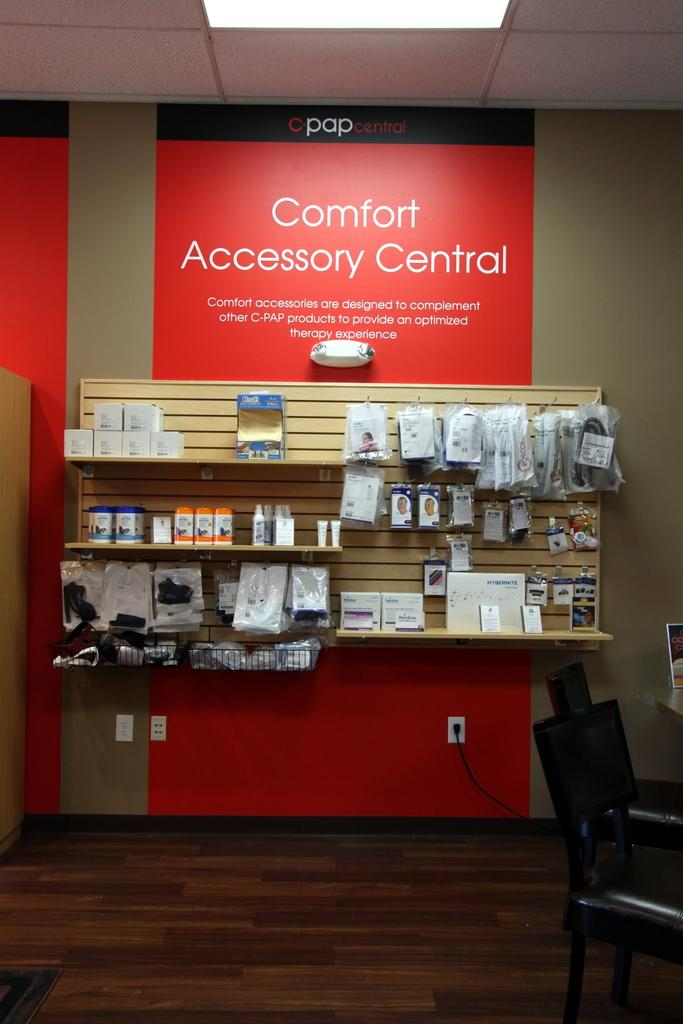<image>
Present a compact description of the photo's key features. A comfort accessory display featuring a variety of products in a store. 